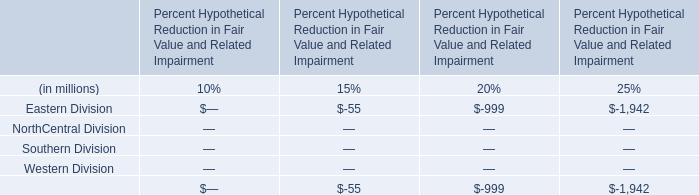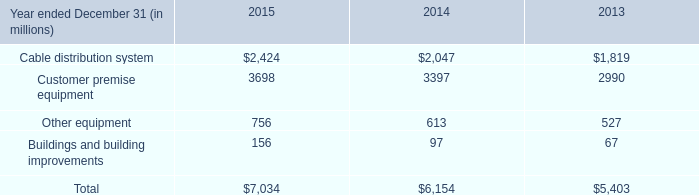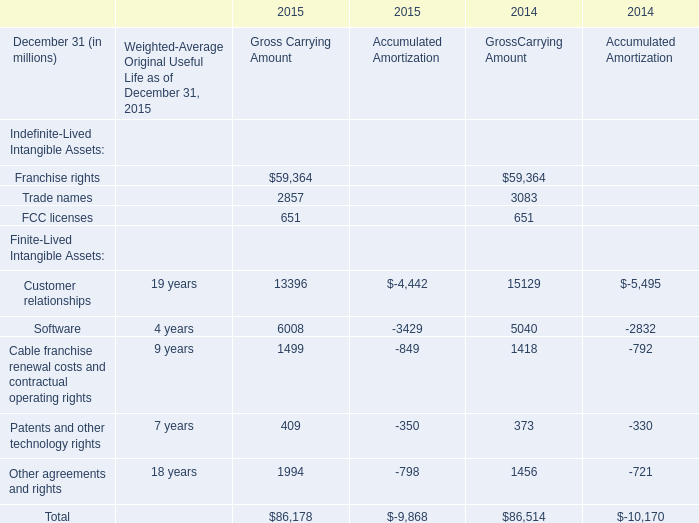If Trade names develops with the same growth rate in 2014, what will it reach in 2015 for Gross Carrying Amount? (in million) 
Computations: (2857 * (1 + ((2857 - 3083) / 3083)))
Answer: 2647.56698. 